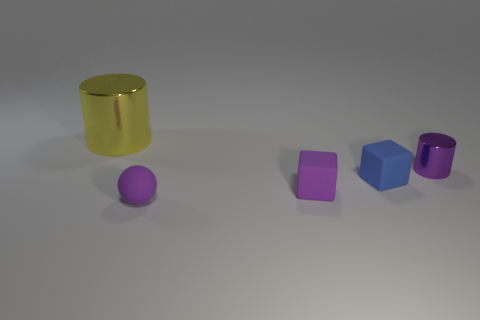Add 5 red shiny balls. How many objects exist? 10 Subtract all cylinders. How many objects are left? 3 Add 1 small brown matte cylinders. How many small brown matte cylinders exist? 1 Subtract 1 purple balls. How many objects are left? 4 Subtract all small cylinders. Subtract all large green blocks. How many objects are left? 4 Add 2 yellow cylinders. How many yellow cylinders are left? 3 